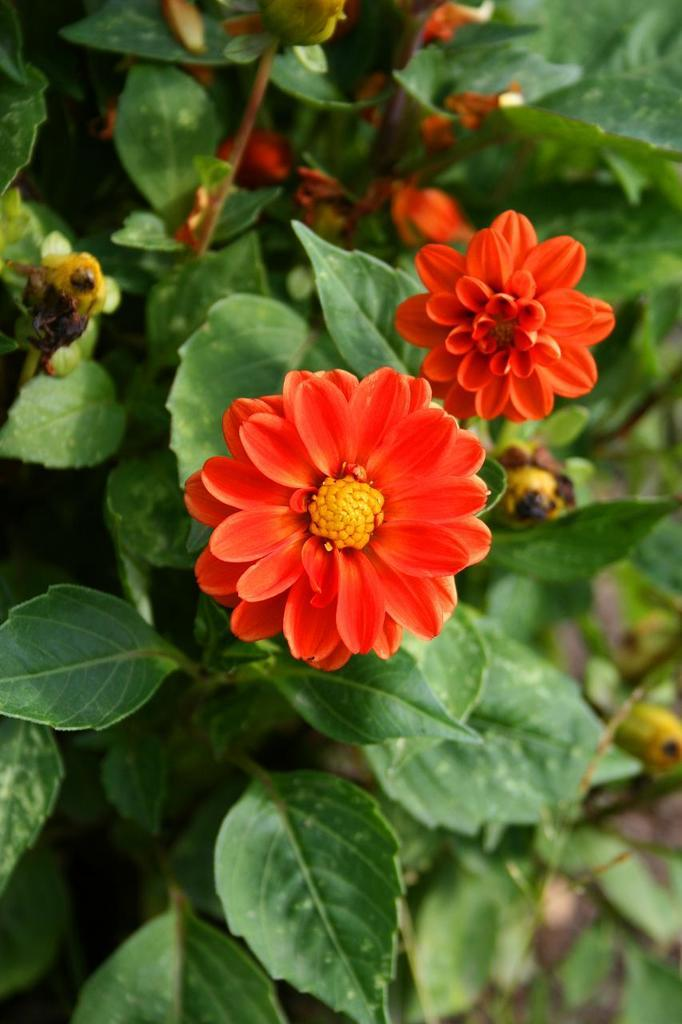What is the main subject of the image? There is a flower in the image. Can you describe the color of the flower? The flower is orange in color. What else can be seen in the background of the image? There are plants with flowers in the background of the image. What type of music is the band playing in the background of the image? There is no band present in the image, so it is not possible to determine what type of music they might be playing. 